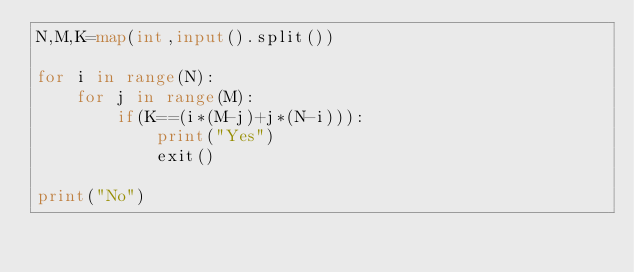<code> <loc_0><loc_0><loc_500><loc_500><_Python_>N,M,K=map(int,input().split())

for i in range(N):
    for j in range(M):
        if(K==(i*(M-j)+j*(N-i))):
            print("Yes")
            exit()

print("No")</code> 